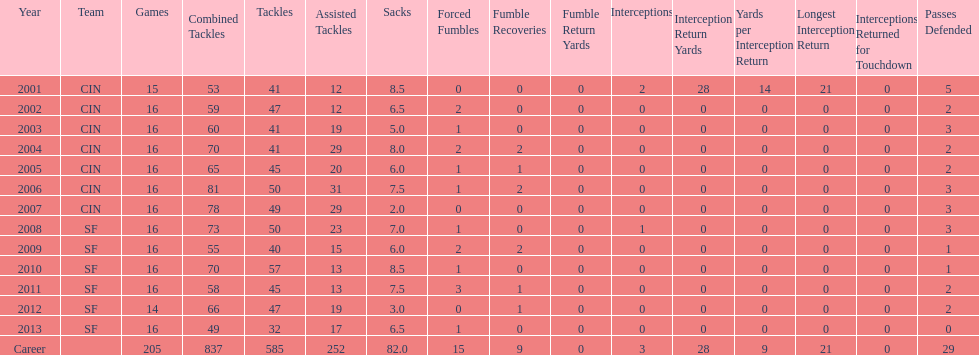What is the mean number of tackles this player has had throughout his career? 45. 